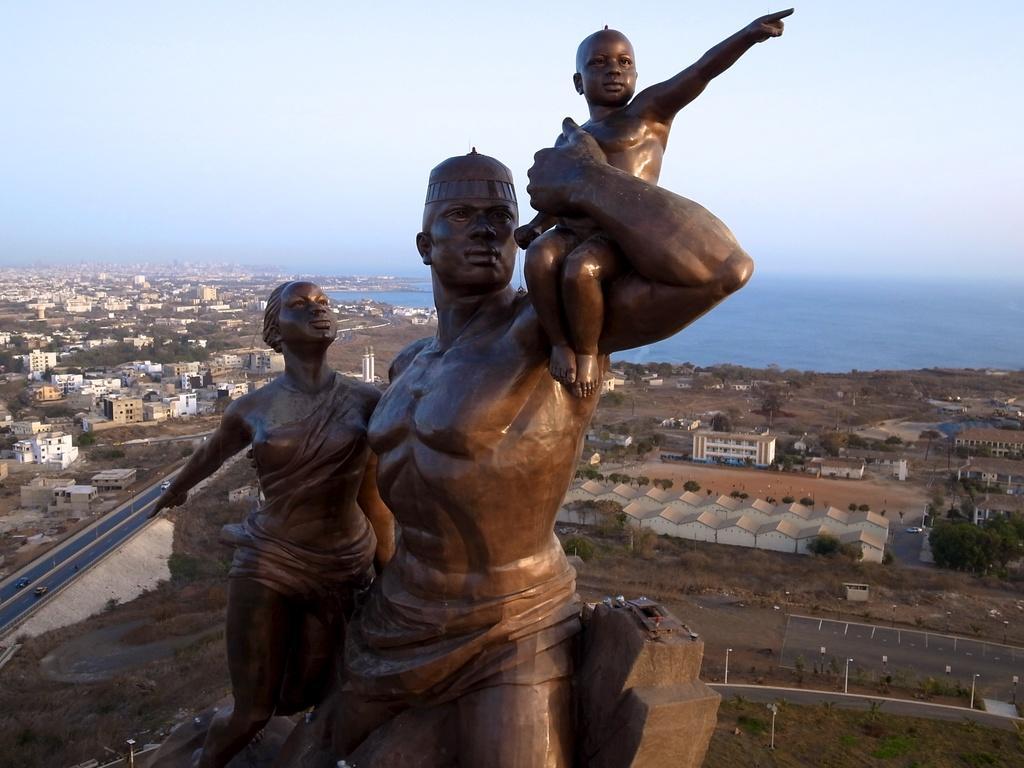Please provide a concise description of this image. In the middle of the image we can see a statue of a lady, man and a child. On the left side of the image we can see the building and the road. On the right side of the object we can see water body and buildings. 